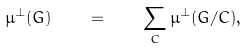<formula> <loc_0><loc_0><loc_500><loc_500>\mu ^ { \perp } ( G ) \quad = \quad \sum _ { C } \mu ^ { \perp } ( G / C ) ,</formula> 